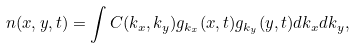<formula> <loc_0><loc_0><loc_500><loc_500>n ( x , y , t ) = \int C ( k _ { x } , k _ { y } ) g _ { k _ { x } } ( x , t ) g _ { k _ { y } } ( y , t ) d k _ { x } d k _ { y } ,</formula> 